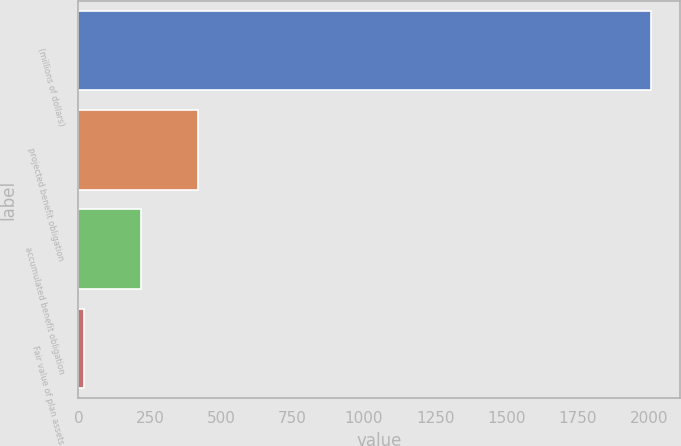Convert chart. <chart><loc_0><loc_0><loc_500><loc_500><bar_chart><fcel>(millions of dollars)<fcel>projected benefit obligation<fcel>accumulated benefit obligation<fcel>Fair value of plan assets<nl><fcel>2006<fcel>418<fcel>219.5<fcel>21<nl></chart> 